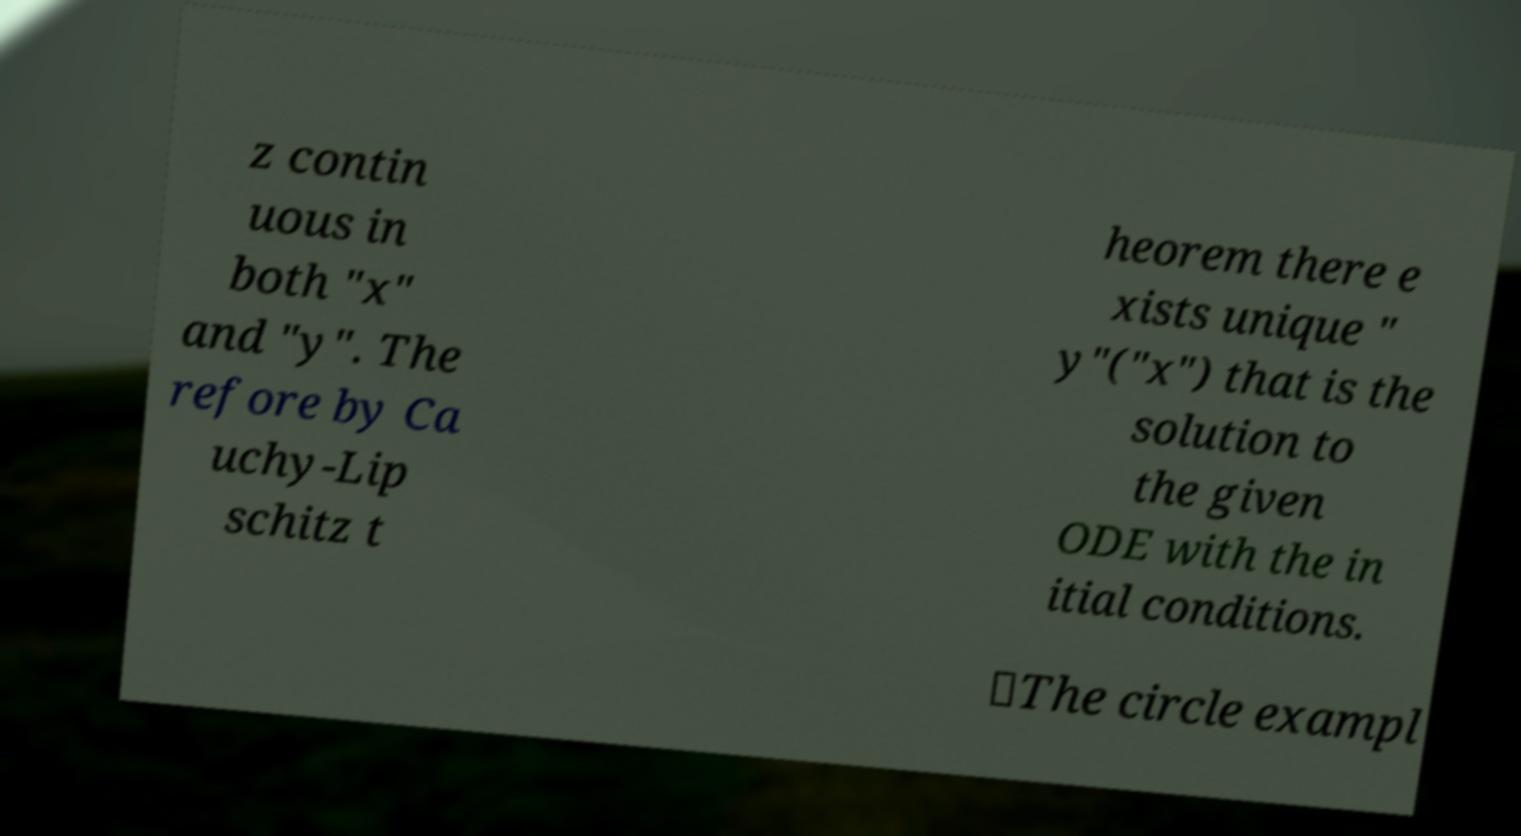I need the written content from this picture converted into text. Can you do that? z contin uous in both "x" and "y". The refore by Ca uchy-Lip schitz t heorem there e xists unique " y"("x") that is the solution to the given ODE with the in itial conditions. ∎The circle exampl 